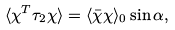<formula> <loc_0><loc_0><loc_500><loc_500>\langle \chi ^ { T } \tau _ { 2 } \chi \rangle = \langle \bar { \chi } \chi \rangle _ { 0 } \sin \alpha ,</formula> 